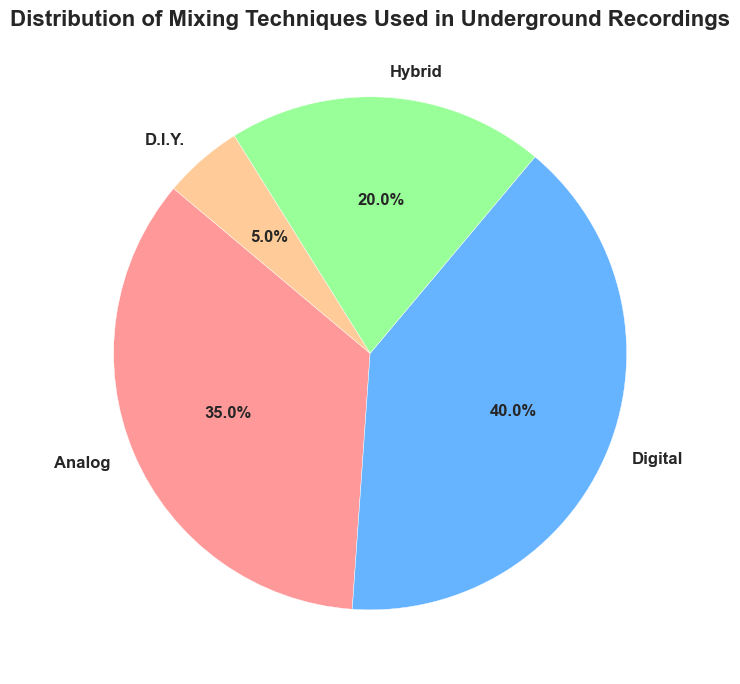What's the most commonly used mixing technique in underground recordings? The pie chart shows different segments with percentages representing each mixing technique. The segment with the largest percentage is the most commonly used technique. Digital has the largest percentage at 40%.
Answer: Digital How much more common is digital mixing compared to analog mixing? The pie chart shows digital mixing at 40% and analog mixing at 35%. To find out how much more common digital is, subtract the percentage of analog from digital: 40% - 35% = 5%.
Answer: 5% What is the combined percentage of analog and hybrid mixing techniques? The pie chart shows analog mixing at 35% and hybrid mixing at 20%. Adding these percentages gives: 35% + 20% = 55%.
Answer: 55% Which mixing technique occupies the smallest portion of the pie chart? The pie chart shows the segments and their respective percentages. The segment with the smallest percentage is the least used technique. D.I.Y. has the smallest percentage at 5%.
Answer: D.I.Y How does the usage of hybrid mixing compare to D.I.Y. mixing? The pie chart shows hybrid mixing at 20% and D.I.Y. mixing at 5%. Hybrid mixing is more common.
Answer: Hybrid is more common What is the difference in percentage between the most and least used mixing techniques? The most used mixing technique is digital at 40% and the least used is D.I.Y. at 5%. The difference is: 40% - 5% = 35%.
Answer: 35% What percentage of all mixing techniques are digital or analog? The pie chart shows digital mixing at 40% and analog mixing at 35%. Adding these percentages gives: 40% + 35% = 75%.
Answer: 75% Which mixing techniques have a smaller percentage of usage compared to analog mixing? The pie chart shows the percentages: digital at 40%, analog at 35%, hybrid at 20%, and D.I.Y. at 5%. Both hybrid and D.I.Y. have smaller percentages compared to analog.
Answer: Hybrid and D.I.Y Based on the colors used in the segments, what color represents hybrid mixing? The pie chart uses different colors for each segment. If hybrid mixing is represented by 20% and is the third segment clockwise from the start angle, which typically follows the order of percentages listed in the data, it is represented by green.
Answer: Green If you sum the percentages of all mixing techniques except digital, what do you get? From the pie chart: analog at 35%, hybrid at 20%, and D.I.Y. at 5%. Adding these gives: 35% + 20% + 5% = 60%.
Answer: 60% 